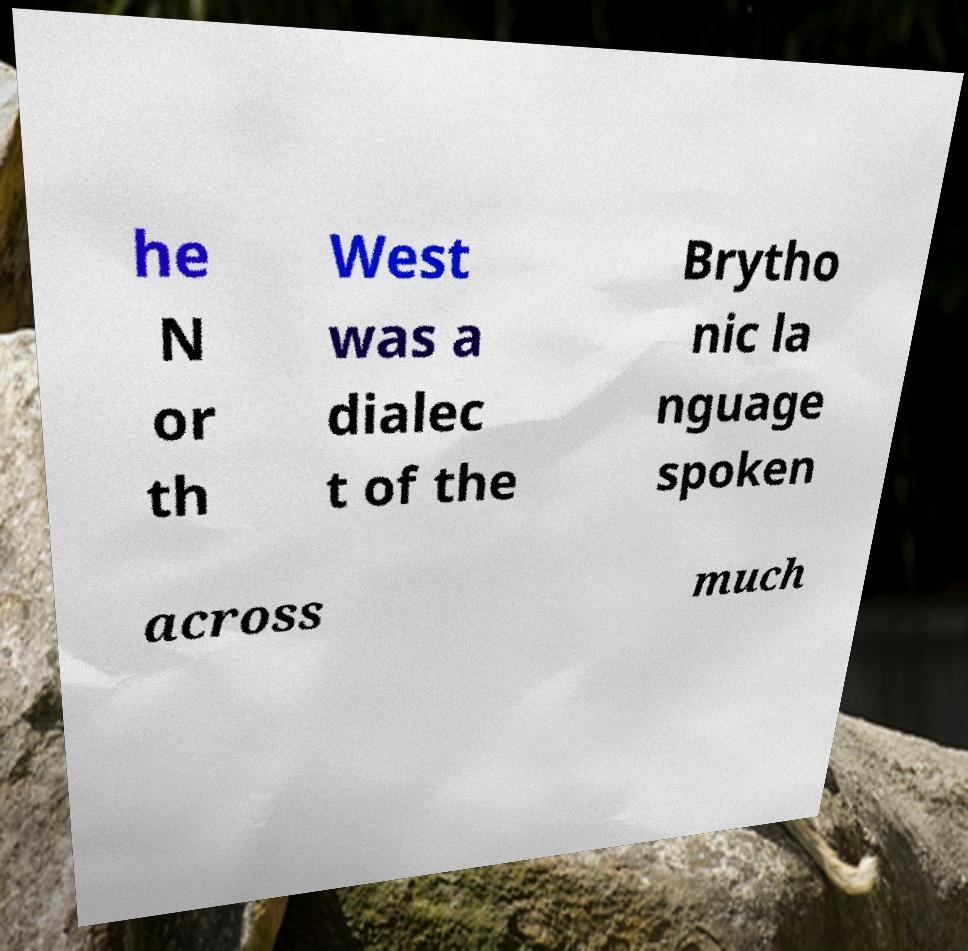Could you extract and type out the text from this image? he N or th West was a dialec t of the Brytho nic la nguage spoken across much 